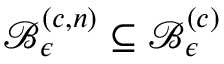Convert formula to latex. <formula><loc_0><loc_0><loc_500><loc_500>\mathcal { B } _ { \epsilon } ^ { \left ( c , n \right ) } \subseteq \mathcal { B } _ { \epsilon } ^ { \left ( c \right ) }</formula> 